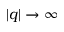<formula> <loc_0><loc_0><loc_500><loc_500>| q | \to \infty</formula> 